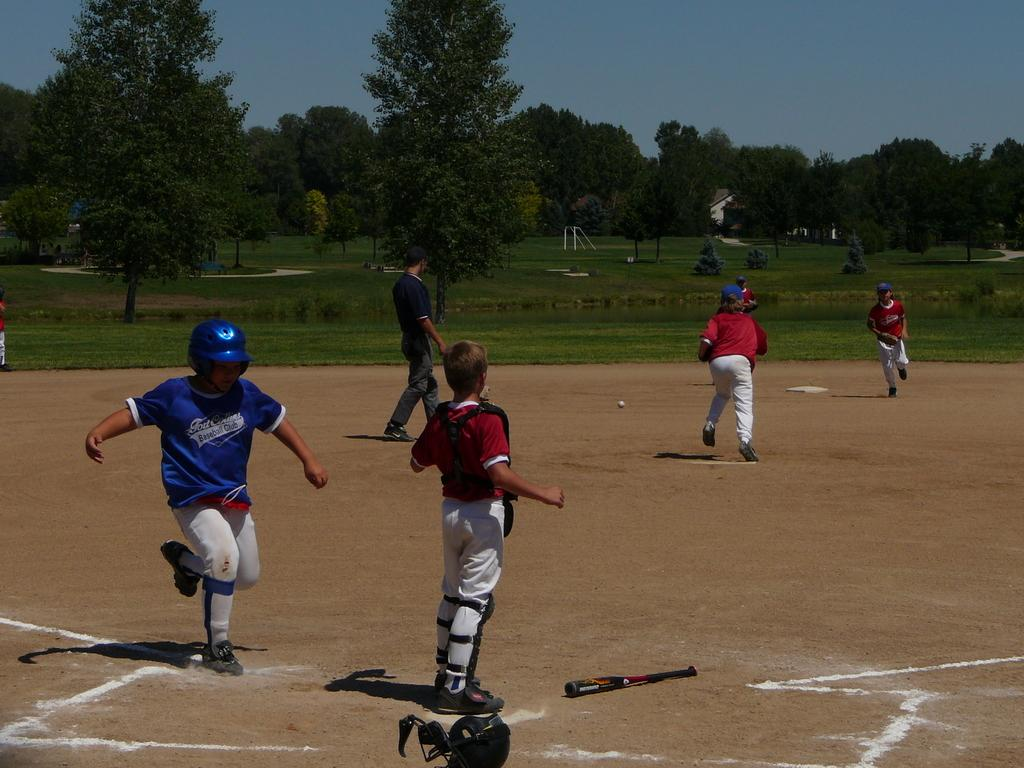Provide a one-sentence caption for the provided image. The kid in the blue uniform is part of a baseball club. 